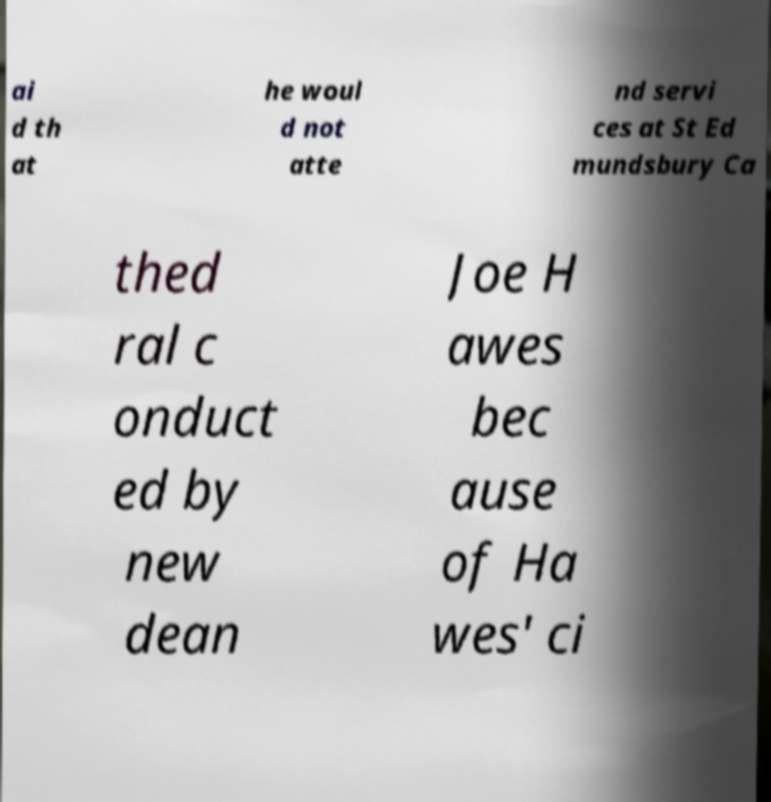What messages or text are displayed in this image? I need them in a readable, typed format. ai d th at he woul d not atte nd servi ces at St Ed mundsbury Ca thed ral c onduct ed by new dean Joe H awes bec ause of Ha wes' ci 